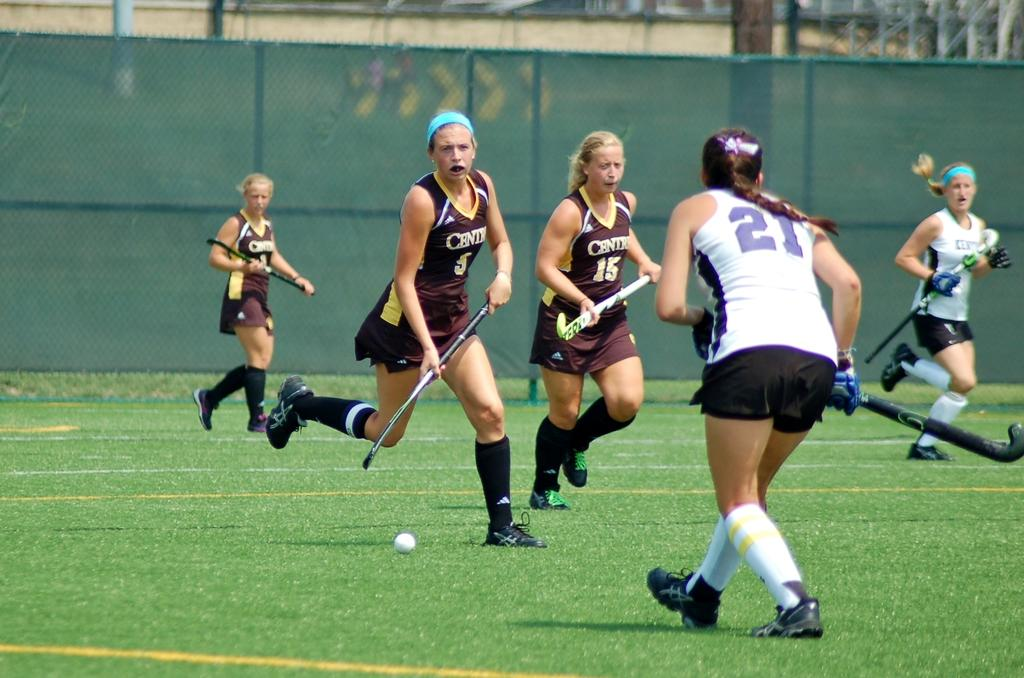What sport are the people playing in the image? The people are playing hockey in the image. Where is the hockey game taking place? The hockey game is taking place on the ground. What structures can be seen in the image? There are poles and a net visible in the image. What is visible in the background of the image? There is a wall visible in the background of the image. How many ducks are playing with the dolls in the image? There are no ducks or dolls present in the image; it features people playing hockey. What type of hat is the goalie wearing in the image? There is no goalie or hat visible in the image; it only shows people playing hockey on the ground. 